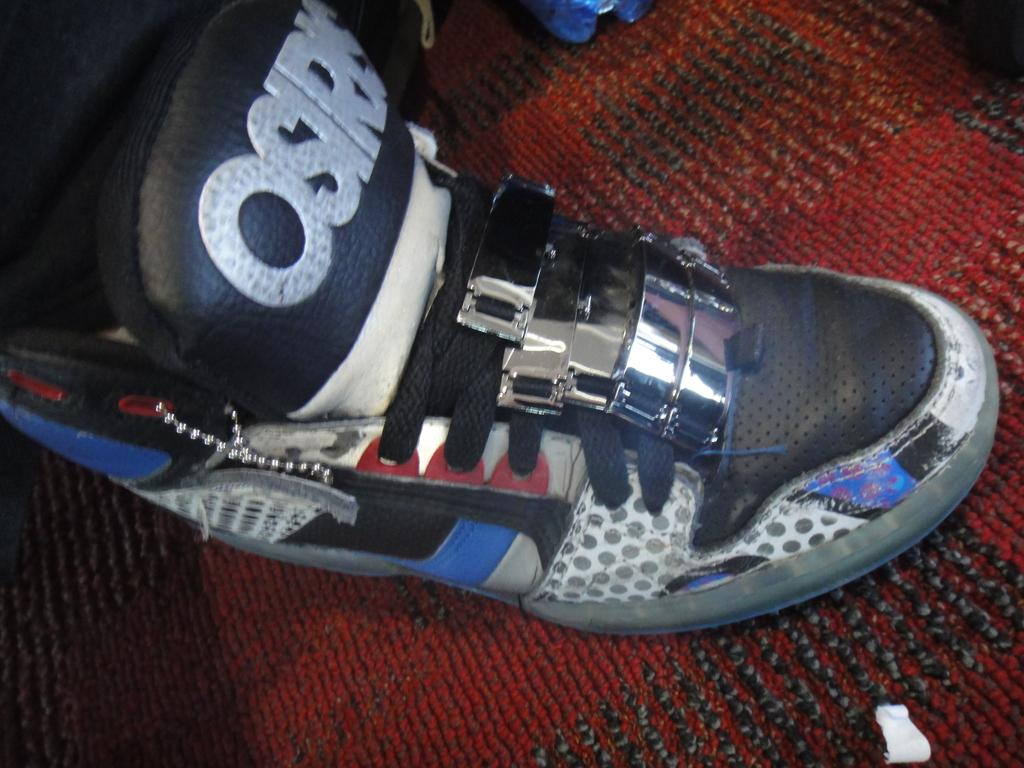<image>
Render a clear and concise summary of the photo. someone is wearing a pair of Osiris skater shoes 